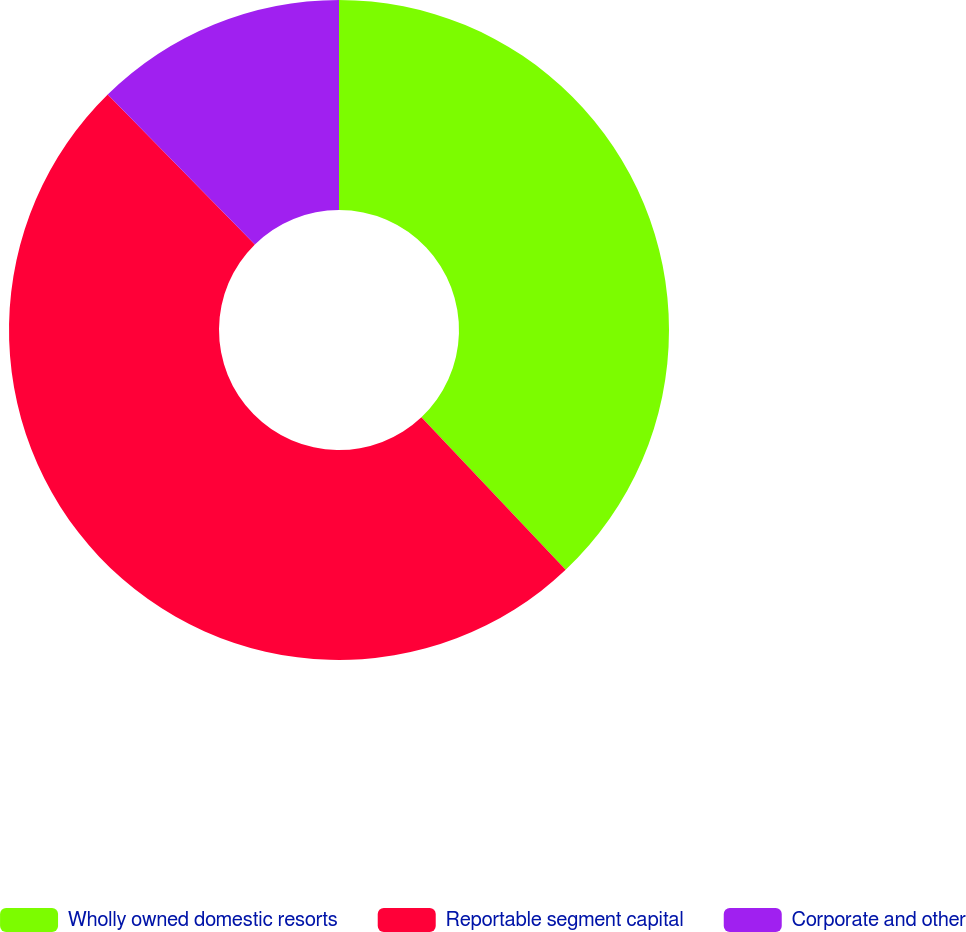Convert chart. <chart><loc_0><loc_0><loc_500><loc_500><pie_chart><fcel>Wholly owned domestic resorts<fcel>Reportable segment capital<fcel>Corporate and other<nl><fcel>37.95%<fcel>49.69%<fcel>12.36%<nl></chart> 